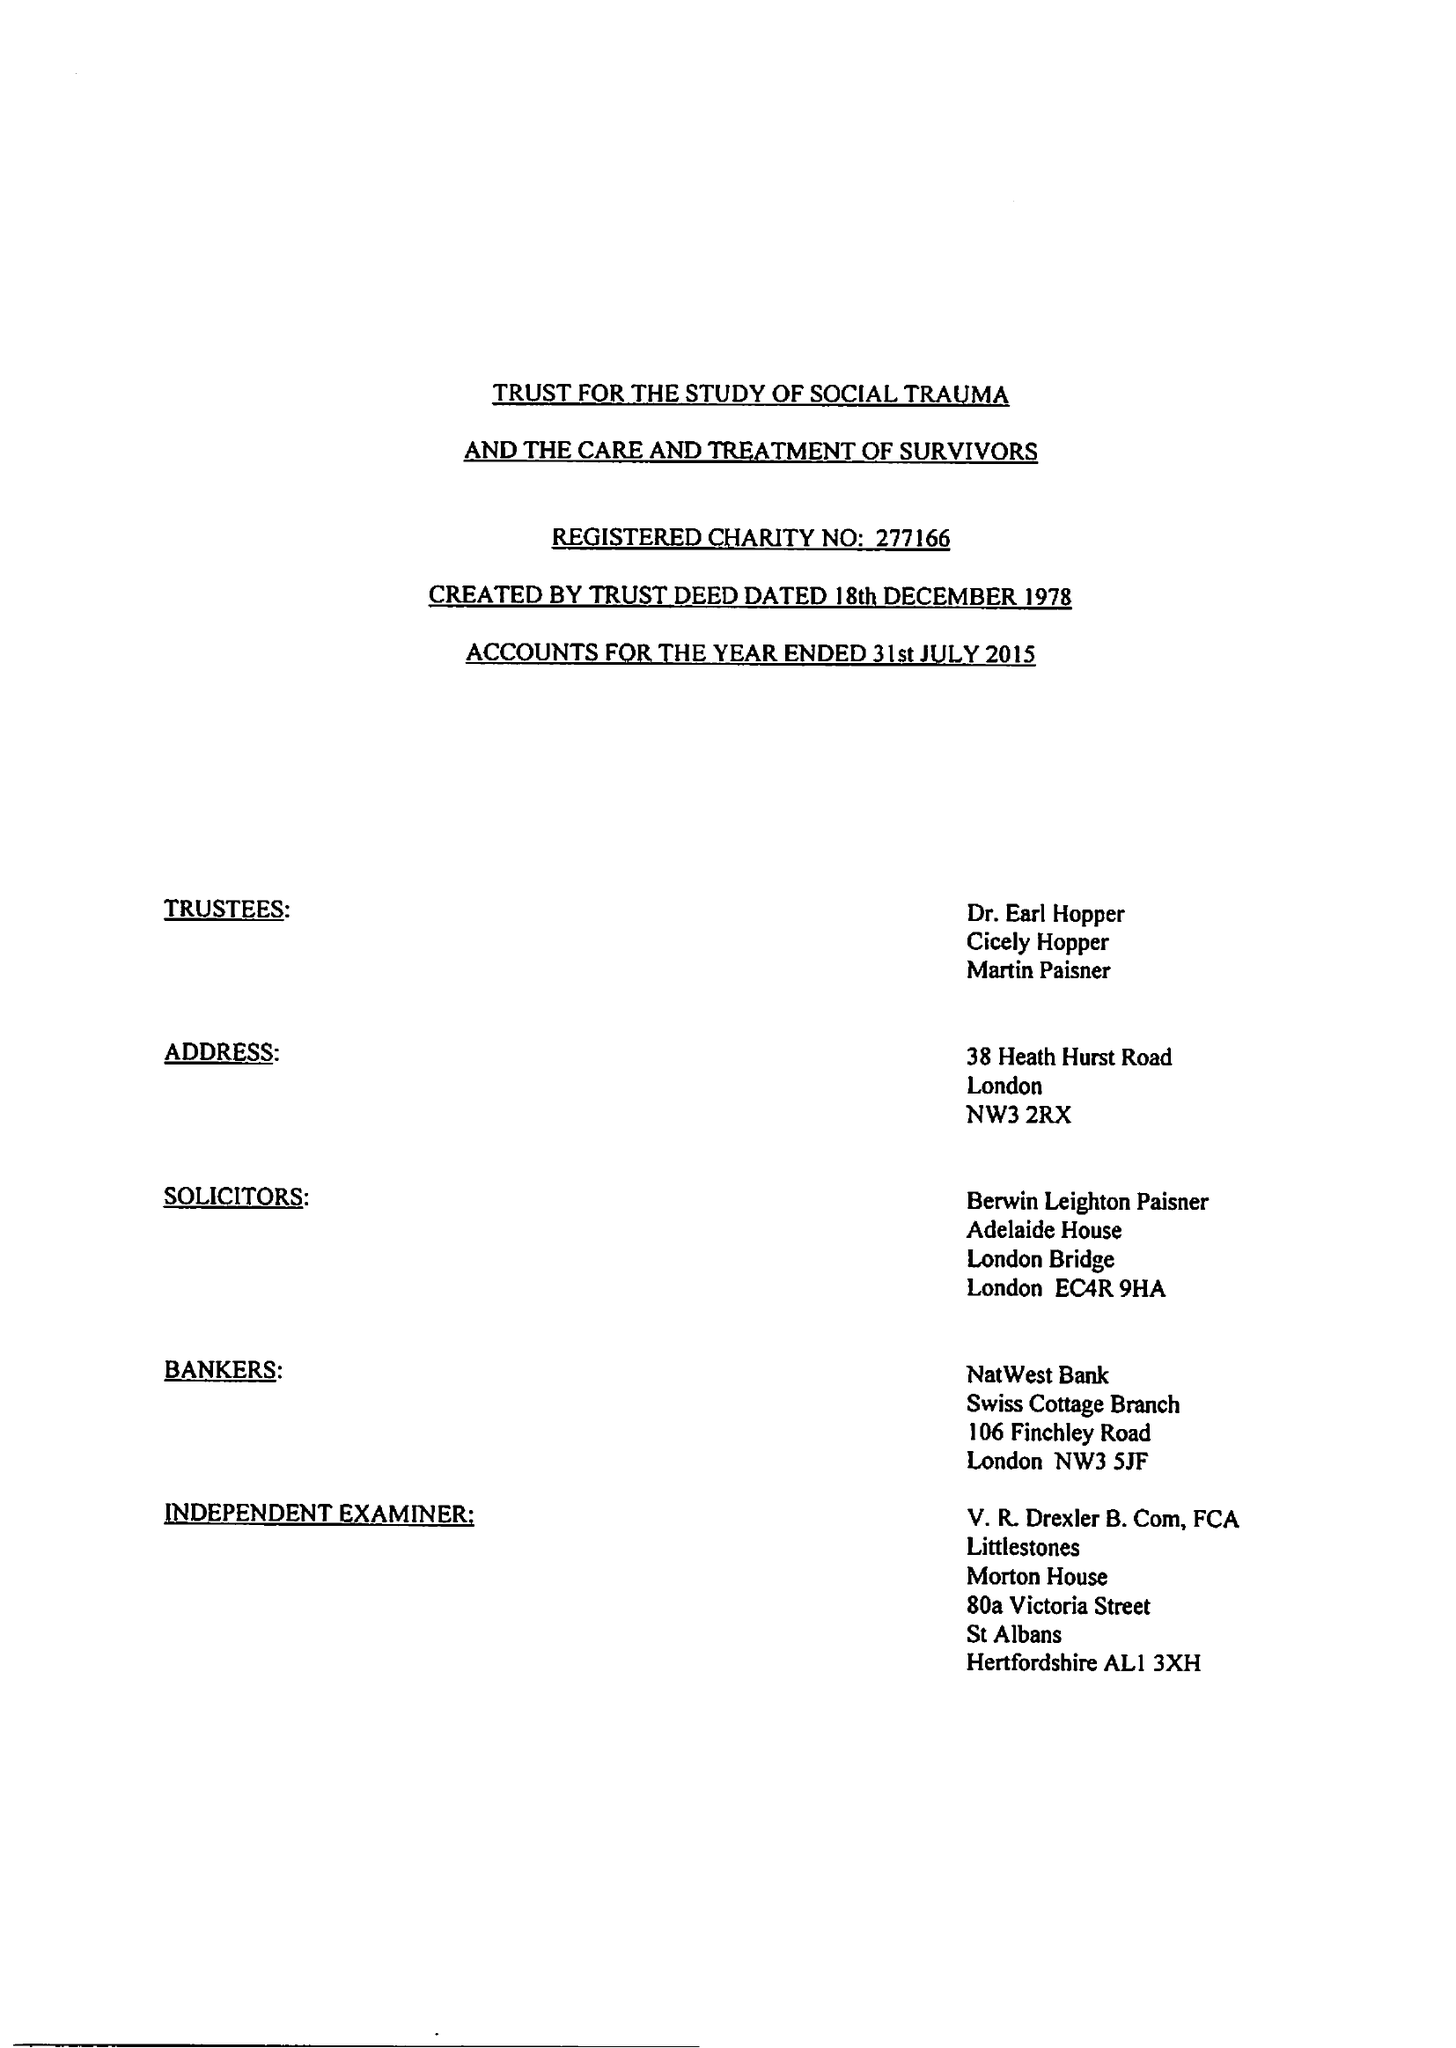What is the value for the report_date?
Answer the question using a single word or phrase. 2015-07-31 